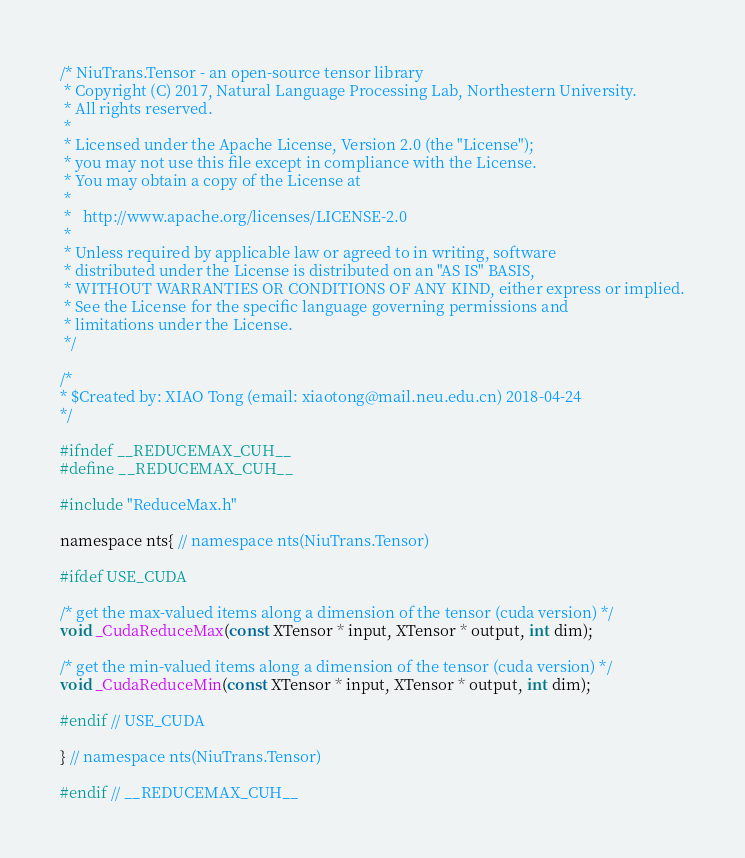Convert code to text. <code><loc_0><loc_0><loc_500><loc_500><_Cuda_>/* NiuTrans.Tensor - an open-source tensor library
 * Copyright (C) 2017, Natural Language Processing Lab, Northestern University. 
 * All rights reserved.
 *
 * Licensed under the Apache License, Version 2.0 (the "License");
 * you may not use this file except in compliance with the License.
 * You may obtain a copy of the License at
 *
 *   http://www.apache.org/licenses/LICENSE-2.0
 *
 * Unless required by applicable law or agreed to in writing, software
 * distributed under the License is distributed on an "AS IS" BASIS,
 * WITHOUT WARRANTIES OR CONDITIONS OF ANY KIND, either express or implied.
 * See the License for the specific language governing permissions and
 * limitations under the License.
 */

/*
* $Created by: XIAO Tong (email: xiaotong@mail.neu.edu.cn) 2018-04-24
*/

#ifndef __REDUCEMAX_CUH__
#define __REDUCEMAX_CUH__

#include "ReduceMax.h"

namespace nts{ // namespace nts(NiuTrans.Tensor)

#ifdef USE_CUDA

/* get the max-valued items along a dimension of the tensor (cuda version) */
void _CudaReduceMax(const XTensor * input, XTensor * output, int dim);

/* get the min-valued items along a dimension of the tensor (cuda version) */
void _CudaReduceMin(const XTensor * input, XTensor * output, int dim);

#endif // USE_CUDA

} // namespace nts(NiuTrans.Tensor)

#endif // __REDUCEMAX_CUH__

</code> 